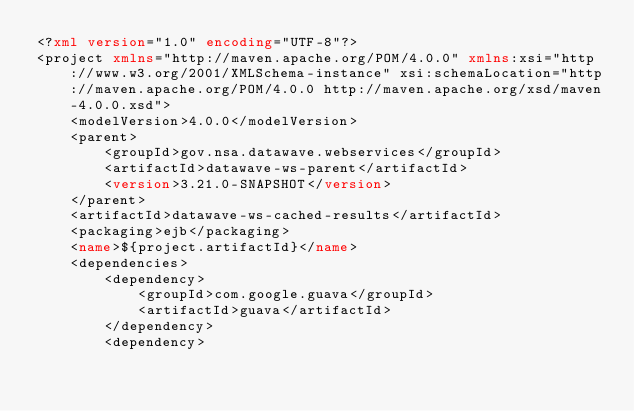Convert code to text. <code><loc_0><loc_0><loc_500><loc_500><_XML_><?xml version="1.0" encoding="UTF-8"?>
<project xmlns="http://maven.apache.org/POM/4.0.0" xmlns:xsi="http://www.w3.org/2001/XMLSchema-instance" xsi:schemaLocation="http://maven.apache.org/POM/4.0.0 http://maven.apache.org/xsd/maven-4.0.0.xsd">
    <modelVersion>4.0.0</modelVersion>
    <parent>
        <groupId>gov.nsa.datawave.webservices</groupId>
        <artifactId>datawave-ws-parent</artifactId>
        <version>3.21.0-SNAPSHOT</version>
    </parent>
    <artifactId>datawave-ws-cached-results</artifactId>
    <packaging>ejb</packaging>
    <name>${project.artifactId}</name>
    <dependencies>
        <dependency>
            <groupId>com.google.guava</groupId>
            <artifactId>guava</artifactId>
        </dependency>
        <dependency></code> 